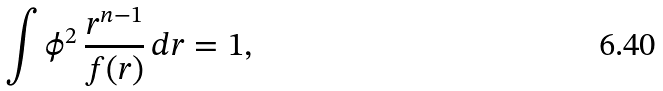<formula> <loc_0><loc_0><loc_500><loc_500>\int \phi ^ { 2 } \, \frac { r ^ { n - 1 } } { f ( r ) } \, d r = 1 ,</formula> 